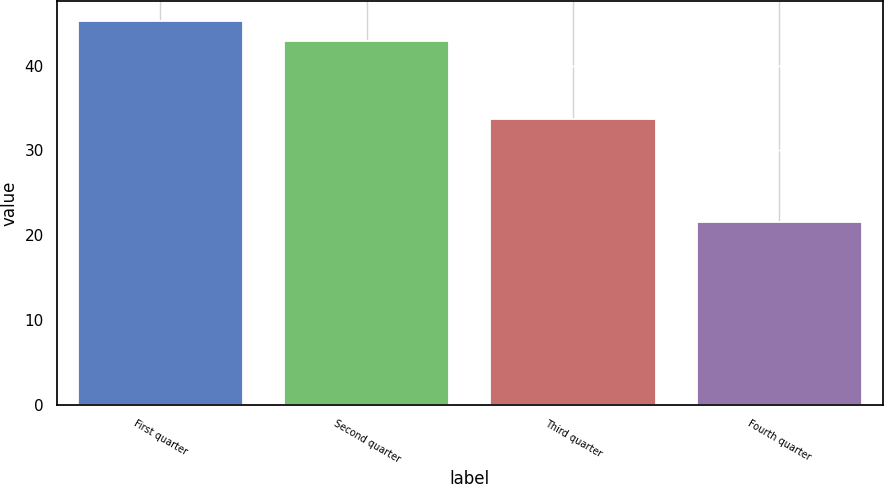<chart> <loc_0><loc_0><loc_500><loc_500><bar_chart><fcel>First quarter<fcel>Second quarter<fcel>Third quarter<fcel>Fourth quarter<nl><fcel>45.31<fcel>42.93<fcel>33.73<fcel>21.54<nl></chart> 